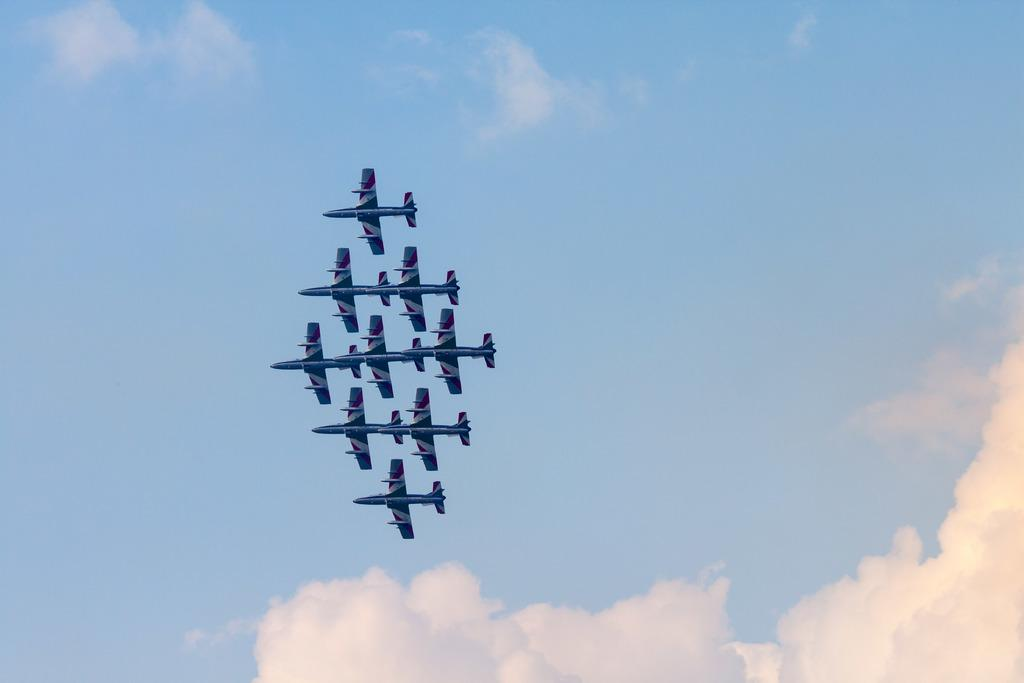What is the main subject of the image? The main subject of the image is planes. Where are the planes located in the image? The planes are flying in the sky. What type of texture can be seen on the blades of the planes in the image? There are no blades present on the planes in the image, as they are not helicopters or propeller-driven aircraft. 